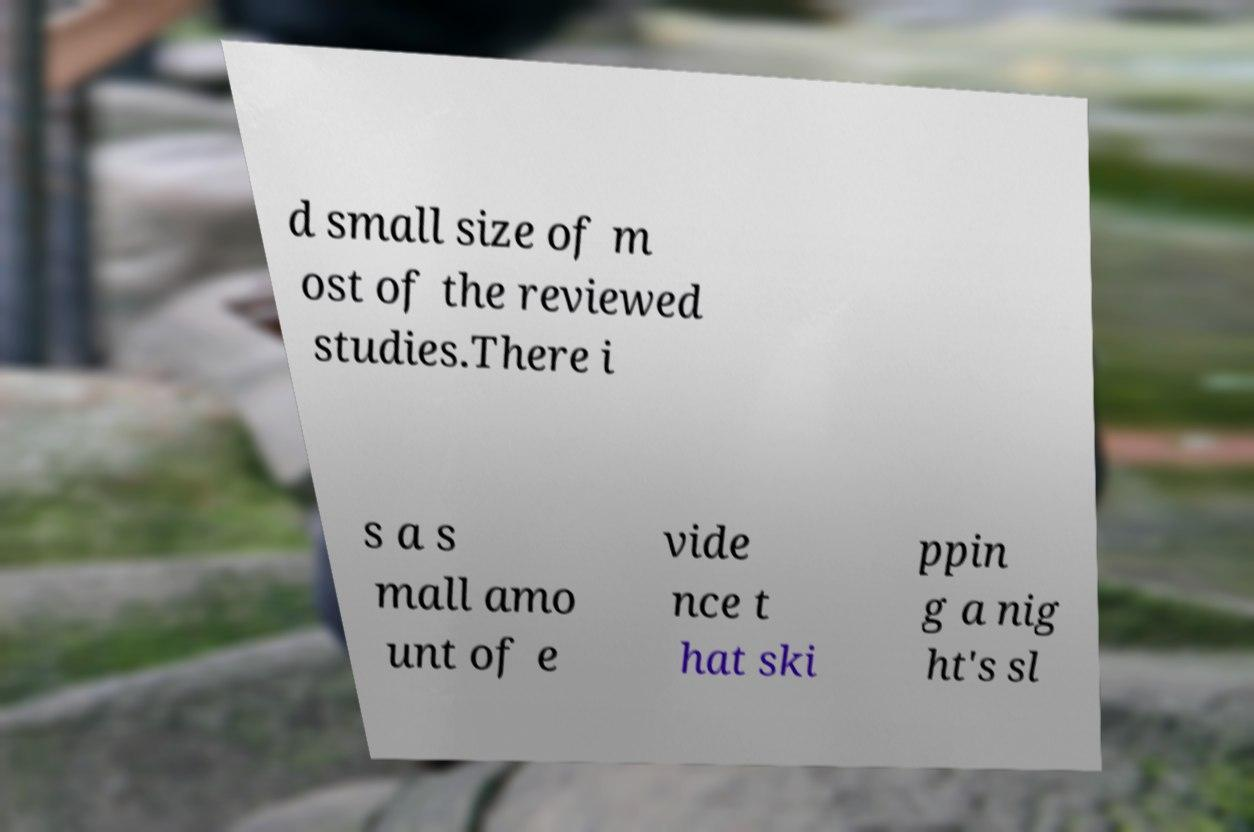Could you extract and type out the text from this image? d small size of m ost of the reviewed studies.There i s a s mall amo unt of e vide nce t hat ski ppin g a nig ht's sl 